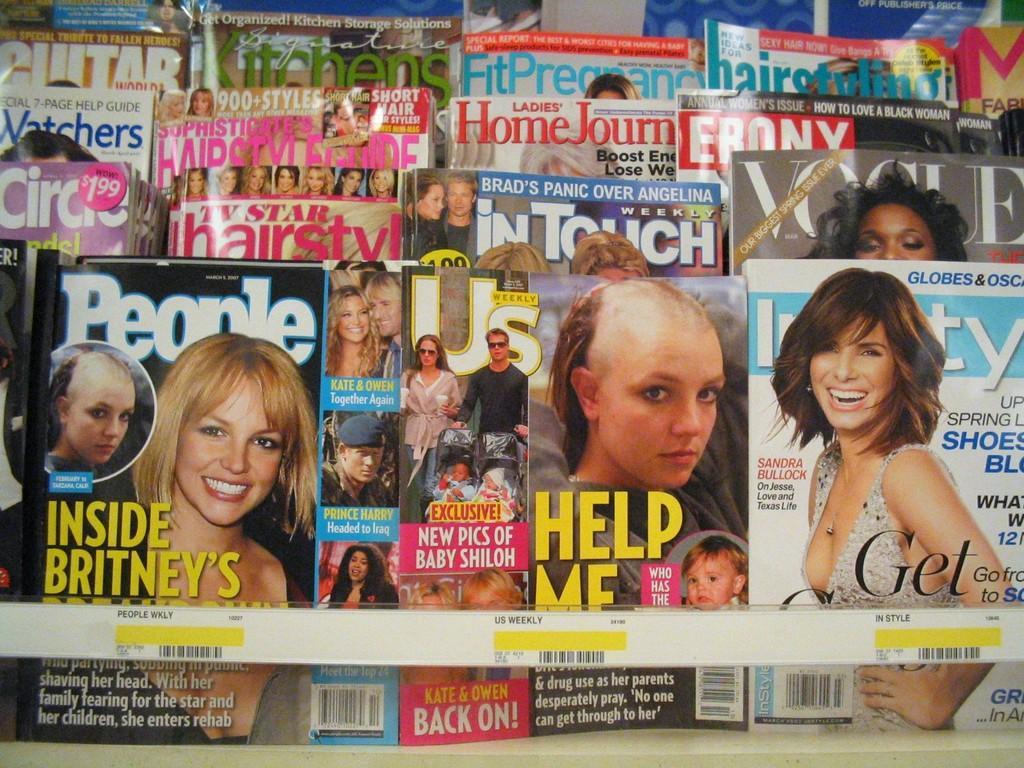How would you summarize this image in a sentence or two? In this image there are magazines on the rack. 